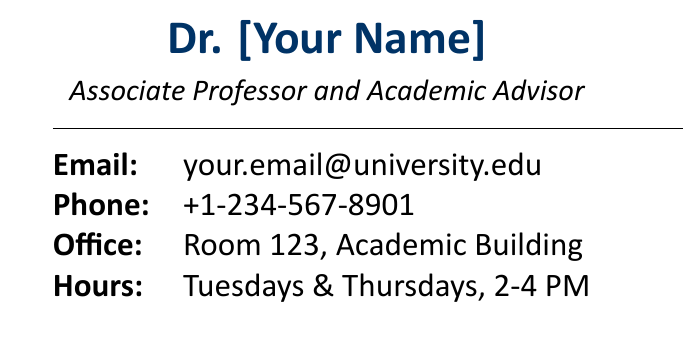What is the name of the professor? The name of the professor is specified at the top of the card, presented in bold text.
Answer: Dr. [Your Name] What is the academic title of the individual? The academic title is given below the name, indicating their position in the university.
Answer: Associate Professor and Academic Advisor What is the email address provided on the card? The email address is clearly listed under the contact information section.
Answer: your.email@university.edu What days are the office hours listed? The office hours are specified as the days when the individual is available for consultation.
Answer: Tuesdays & Thursdays What level of mentorship is available for undergraduates? The card provides a specific mention of the availability of mentorship for a certain student level.
Answer: Available 